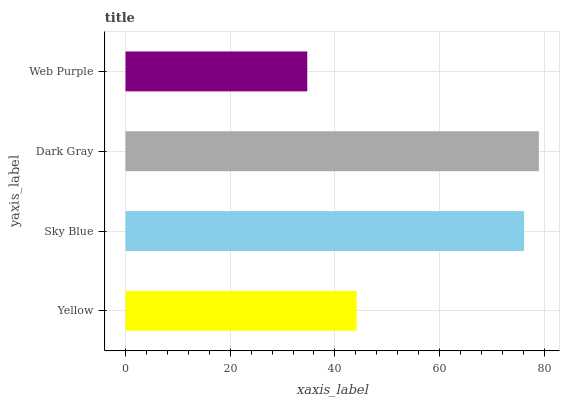Is Web Purple the minimum?
Answer yes or no. Yes. Is Dark Gray the maximum?
Answer yes or no. Yes. Is Sky Blue the minimum?
Answer yes or no. No. Is Sky Blue the maximum?
Answer yes or no. No. Is Sky Blue greater than Yellow?
Answer yes or no. Yes. Is Yellow less than Sky Blue?
Answer yes or no. Yes. Is Yellow greater than Sky Blue?
Answer yes or no. No. Is Sky Blue less than Yellow?
Answer yes or no. No. Is Sky Blue the high median?
Answer yes or no. Yes. Is Yellow the low median?
Answer yes or no. Yes. Is Web Purple the high median?
Answer yes or no. No. Is Dark Gray the low median?
Answer yes or no. No. 